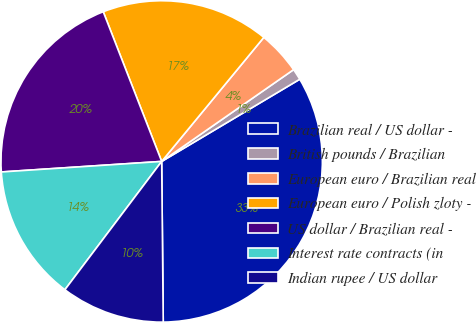<chart> <loc_0><loc_0><loc_500><loc_500><pie_chart><fcel>Brazilian real / US dollar -<fcel>British pounds / Brazilian<fcel>European euro / Brazilian real<fcel>European euro / Polish zloty -<fcel>US dollar / Brazilian real -<fcel>Interest rate contracts (in<fcel>Indian rupee / US dollar<nl><fcel>33.39%<fcel>1.13%<fcel>4.36%<fcel>16.89%<fcel>20.12%<fcel>13.67%<fcel>10.44%<nl></chart> 